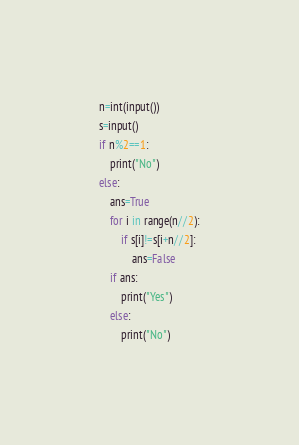<code> <loc_0><loc_0><loc_500><loc_500><_Python_>n=int(input())
s=input()
if n%2==1:
    print("No")
else:
    ans=True
    for i in range(n//2):
        if s[i]!=s[i+n//2]:
            ans=False
    if ans:
        print("Yes")
    else:
        print("No")</code> 